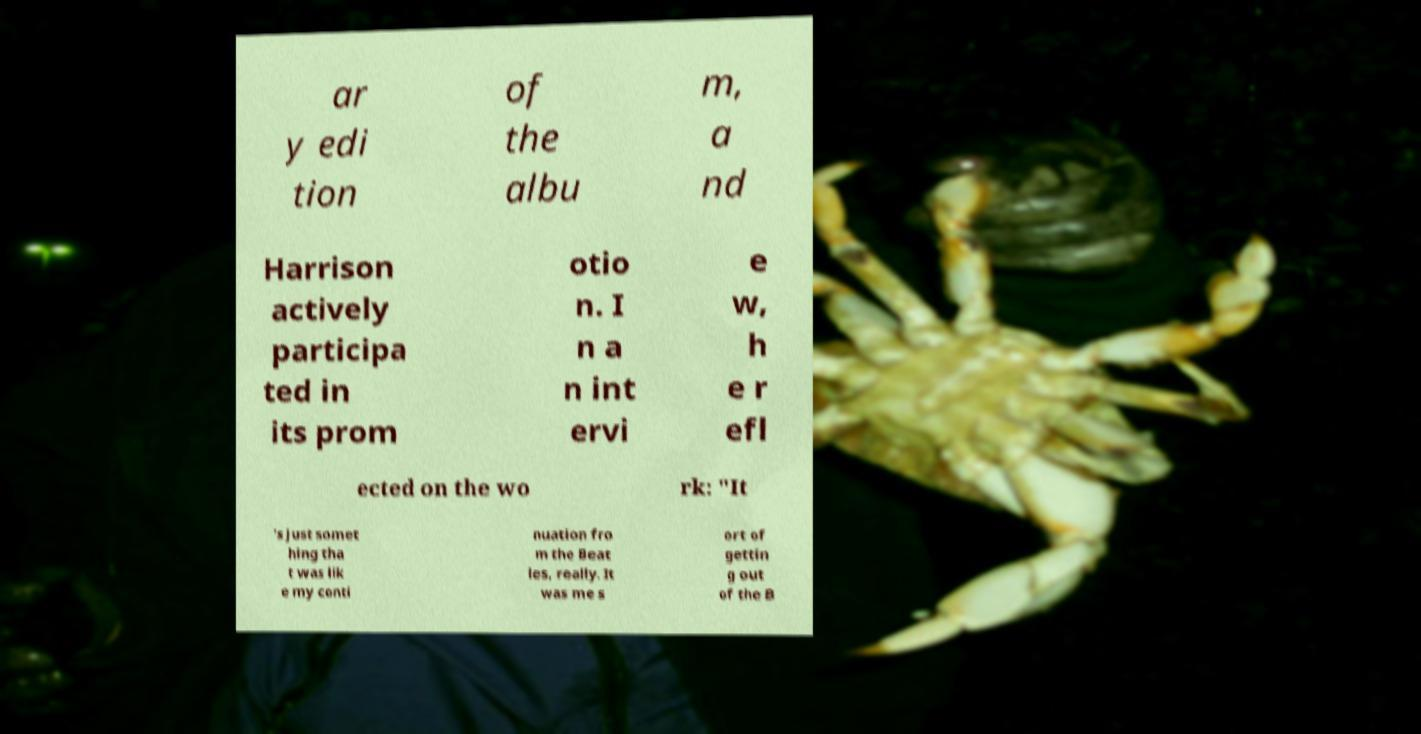What messages or text are displayed in this image? I need them in a readable, typed format. ar y edi tion of the albu m, a nd Harrison actively participa ted in its prom otio n. I n a n int ervi e w, h e r efl ected on the wo rk: "It 's just somet hing tha t was lik e my conti nuation fro m the Beat les, really. It was me s ort of gettin g out of the B 